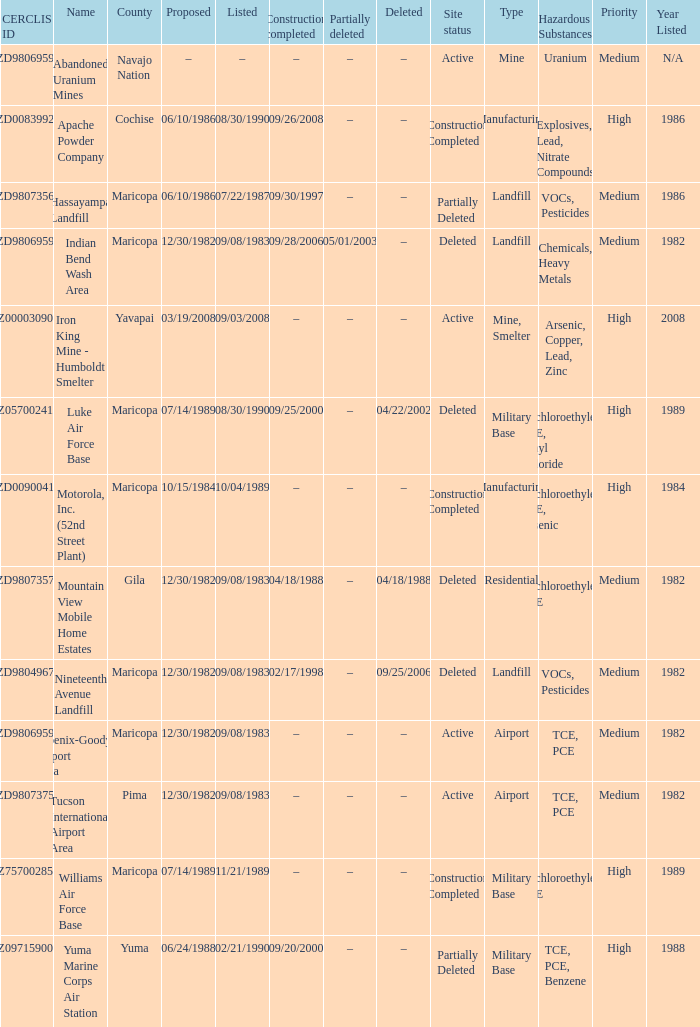When was the site partially deleted when the cerclis id is az7570028582? –. 